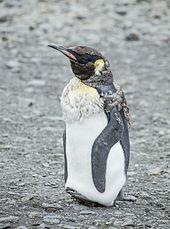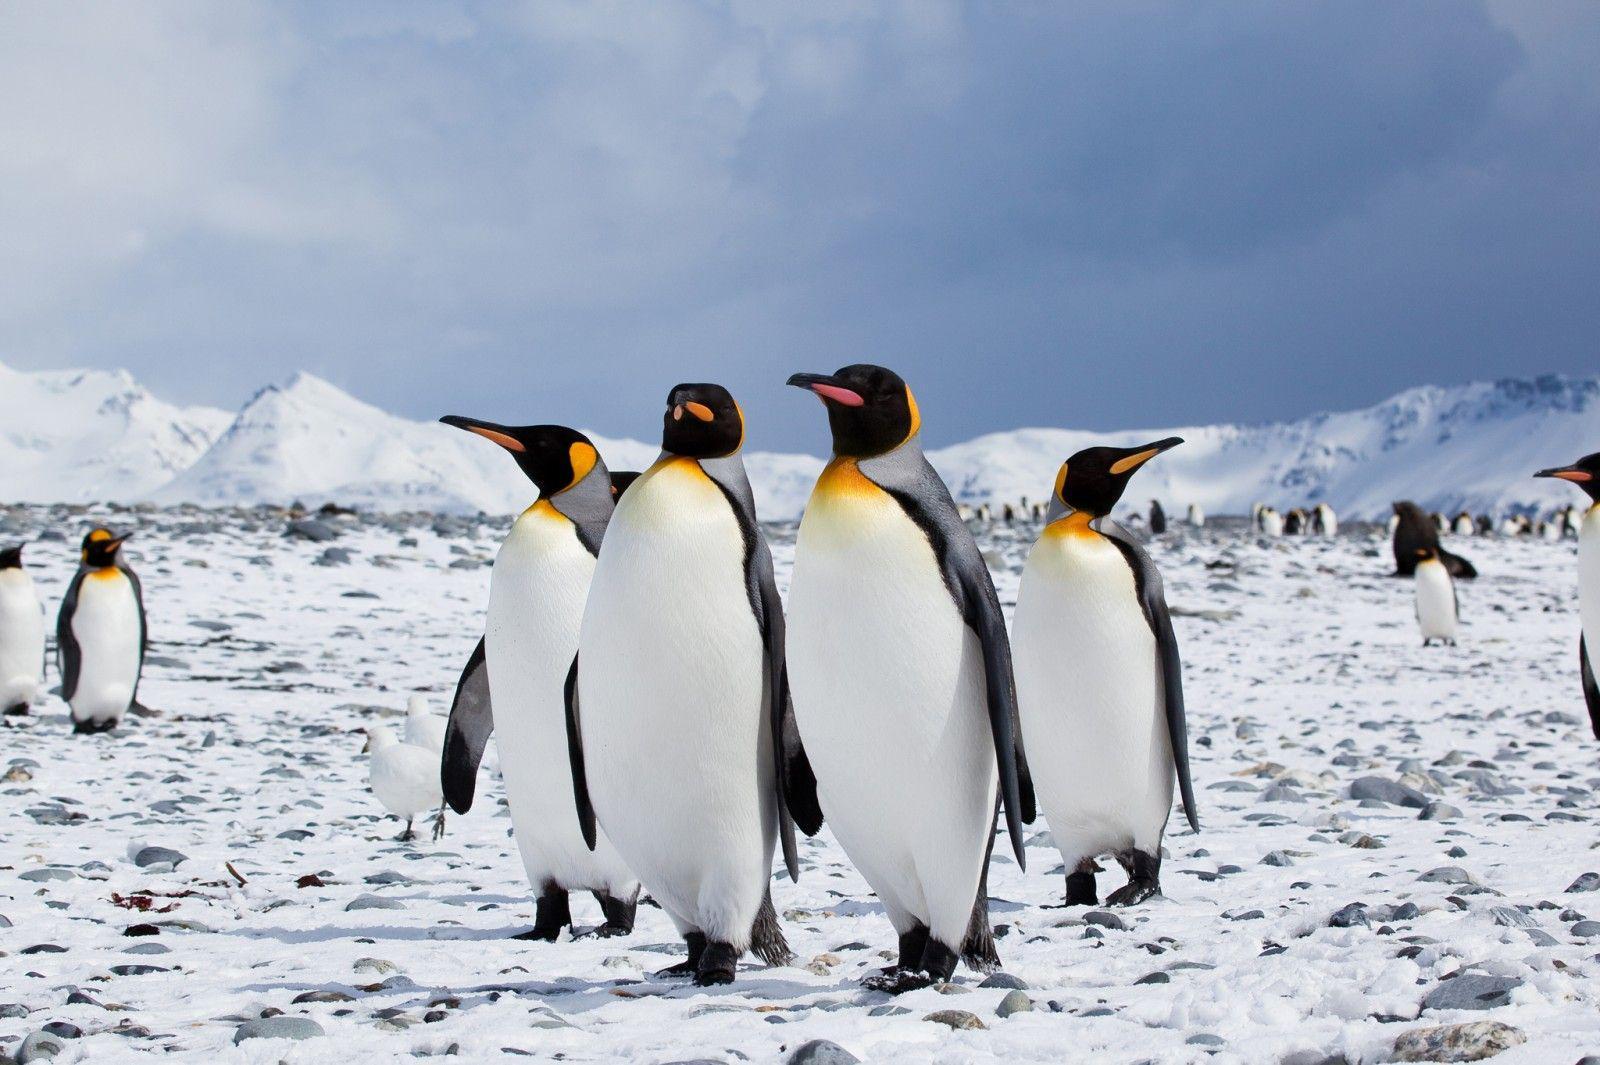The first image is the image on the left, the second image is the image on the right. For the images displayed, is the sentence "There are two adult penguins standing with a baby penguin in the image on the right." factually correct? Answer yes or no. No. The first image is the image on the left, the second image is the image on the right. Assess this claim about the two images: "Both images contain the same number of penguins in the foreground.". Correct or not? Answer yes or no. No. The first image is the image on the left, the second image is the image on the right. Analyze the images presented: Is the assertion "At least one image contains at least five penguins." valid? Answer yes or no. Yes. 